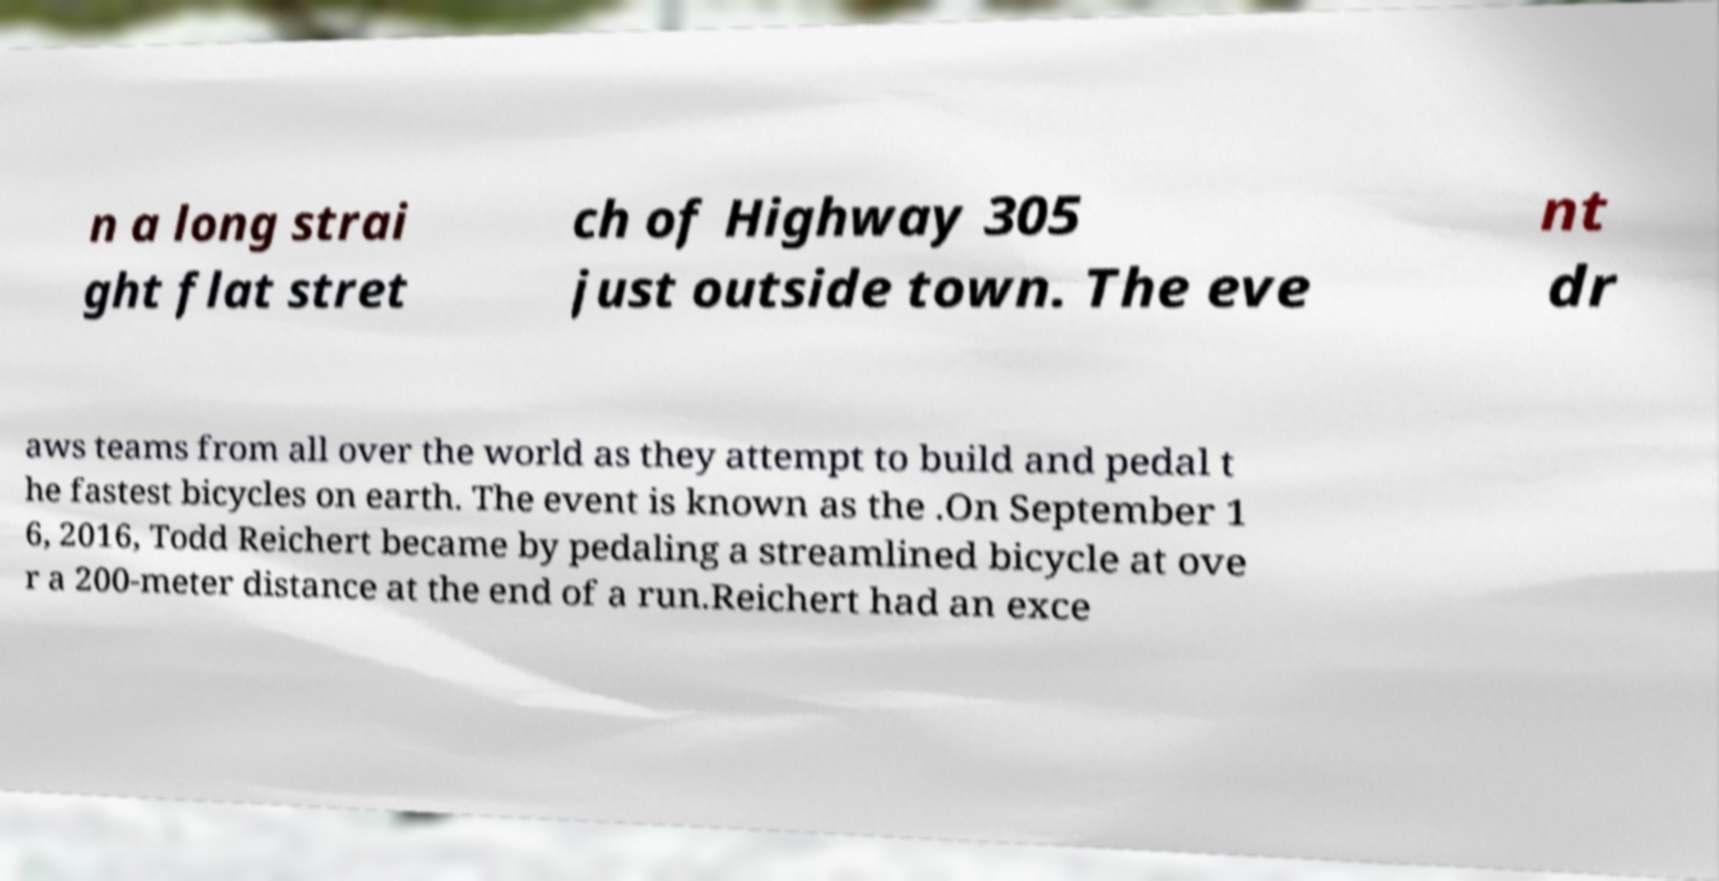Please identify and transcribe the text found in this image. n a long strai ght flat stret ch of Highway 305 just outside town. The eve nt dr aws teams from all over the world as they attempt to build and pedal t he fastest bicycles on earth. The event is known as the .On September 1 6, 2016, Todd Reichert became by pedaling a streamlined bicycle at ove r a 200-meter distance at the end of a run.Reichert had an exce 